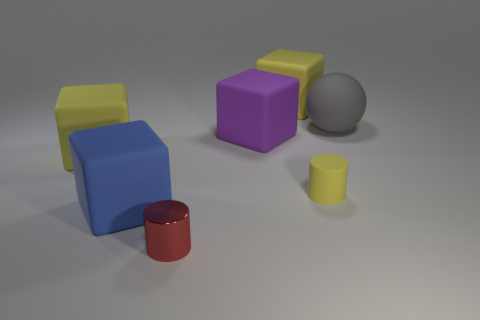If you had to associate this arrangement with an idea or theme, what would it be? This arrangement of shapes and colors might symbolize diversity and unity. The different colors and shapes could represent various individuals or elements, and their close placement suggests a harmonious coexistence or an organized structure. 